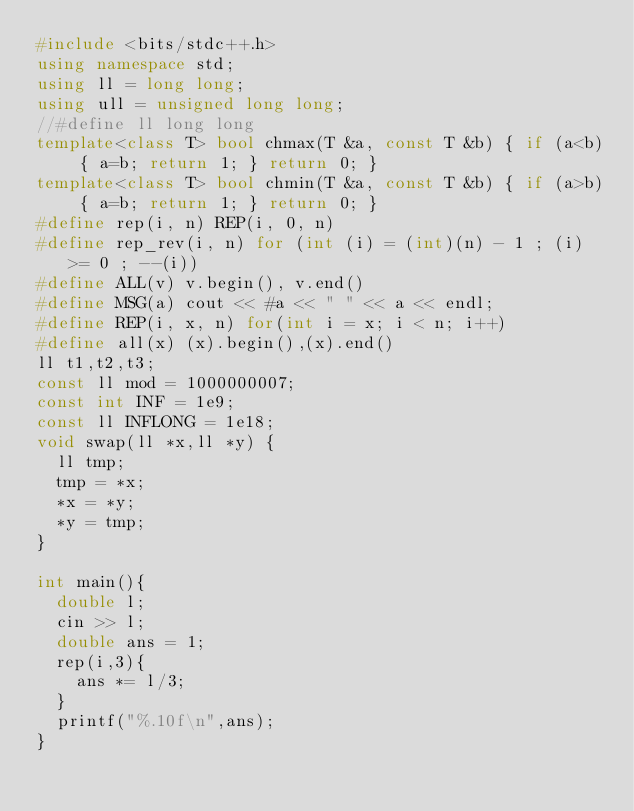<code> <loc_0><loc_0><loc_500><loc_500><_C++_>#include <bits/stdc++.h>
using namespace std;
using ll = long long;
using ull = unsigned long long;
//#define ll long long
template<class T> bool chmax(T &a, const T &b) { if (a<b) { a=b; return 1; } return 0; }
template<class T> bool chmin(T &a, const T &b) { if (a>b) { a=b; return 1; } return 0; }
#define rep(i, n) REP(i, 0, n)
#define rep_rev(i, n) for (int (i) = (int)(n) - 1 ; (i) >= 0 ; --(i))
#define ALL(v) v.begin(), v.end()
#define MSG(a) cout << #a << " " << a << endl;
#define REP(i, x, n) for(int i = x; i < n; i++)
#define all(x) (x).begin(),(x).end()
ll t1,t2,t3;
const ll mod = 1000000007;
const int INF = 1e9;
const ll INFLONG = 1e18;
void swap(ll *x,ll *y) {
  ll tmp;
  tmp = *x;
  *x = *y;
  *y = tmp;
}

int main(){
  double l;
  cin >> l;
  double ans = 1;
  rep(i,3){
    ans *= l/3;
  }
  printf("%.10f\n",ans);
}</code> 